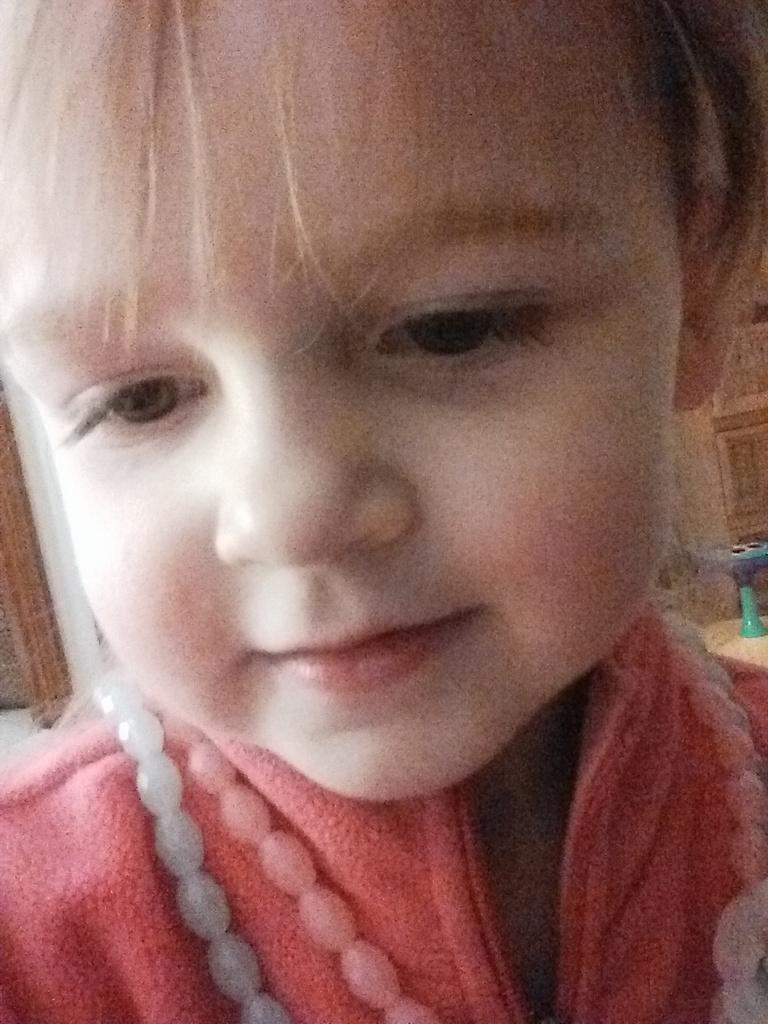Describe this image in one or two sentences. In this picture, we can see a kid wearing a red color shirt. In the background, we can see a door. 